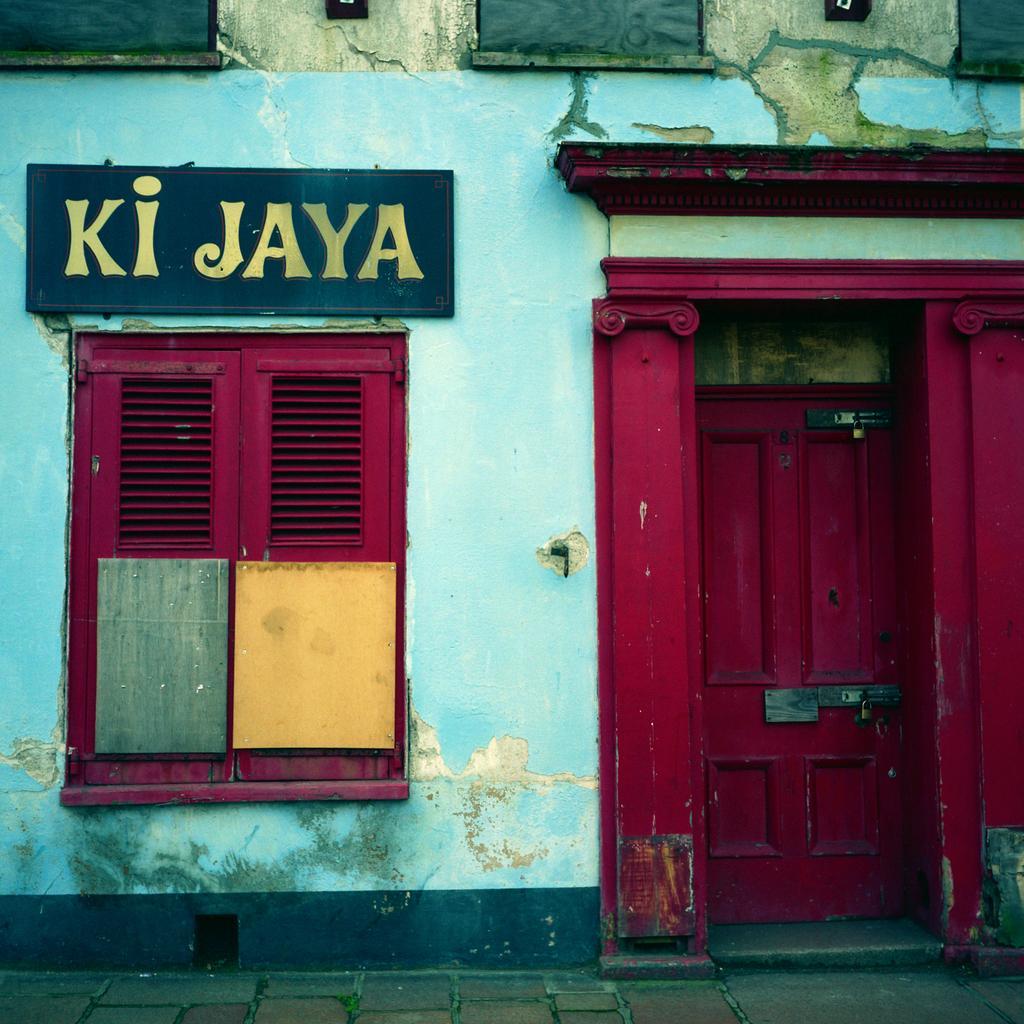How would you summarize this image in a sentence or two? In this picture we can see the wall, board, window, door, locks and objects. At the bottom portion of the picture we can see the pathway. 